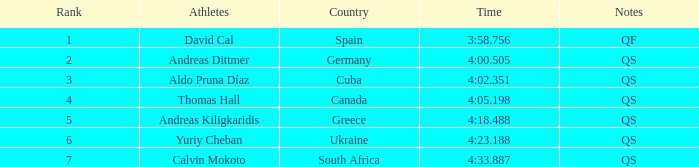What are the observations for the spanish athlete? QF. 